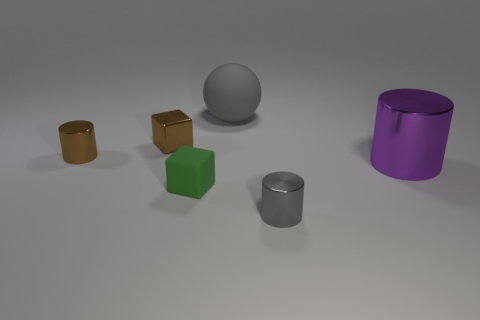Is the number of large purple metallic things that are left of the large gray thing less than the number of tiny green cubes in front of the rubber block?
Keep it short and to the point. No. What is the shape of the metallic object that is behind the gray cylinder and right of the big rubber object?
Offer a very short reply. Cylinder. The purple object that is the same material as the tiny brown cylinder is what size?
Your response must be concise. Large. Is the color of the sphere the same as the large cylinder that is in front of the tiny metal block?
Ensure brevity in your answer.  No. What is the material of the small thing that is both behind the large purple cylinder and to the right of the brown cylinder?
Your answer should be compact. Metal. There is a cylinder that is the same color as the large rubber sphere; what is its size?
Offer a terse response. Small. There is a small thing that is to the left of the tiny shiny block; is its shape the same as the tiny metallic object to the right of the large gray matte sphere?
Keep it short and to the point. Yes. Are there any rubber cubes?
Ensure brevity in your answer.  Yes. What is the color of the other thing that is the same shape as the green rubber object?
Offer a terse response. Brown. What is the color of the matte thing that is the same size as the brown cube?
Offer a terse response. Green. 